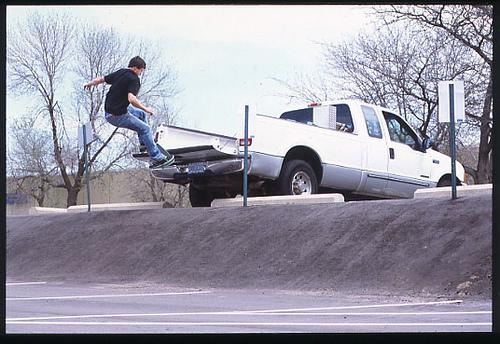What is on the car?
Write a very short answer. Skateboarder. What color is the truck?
Be succinct. White. How many people in the picture?
Short answer required. 1. What kind of vehicle is picture?
Short answer required. Truck. What is the skateboarder leaping over?
Be succinct. Back of truck. 